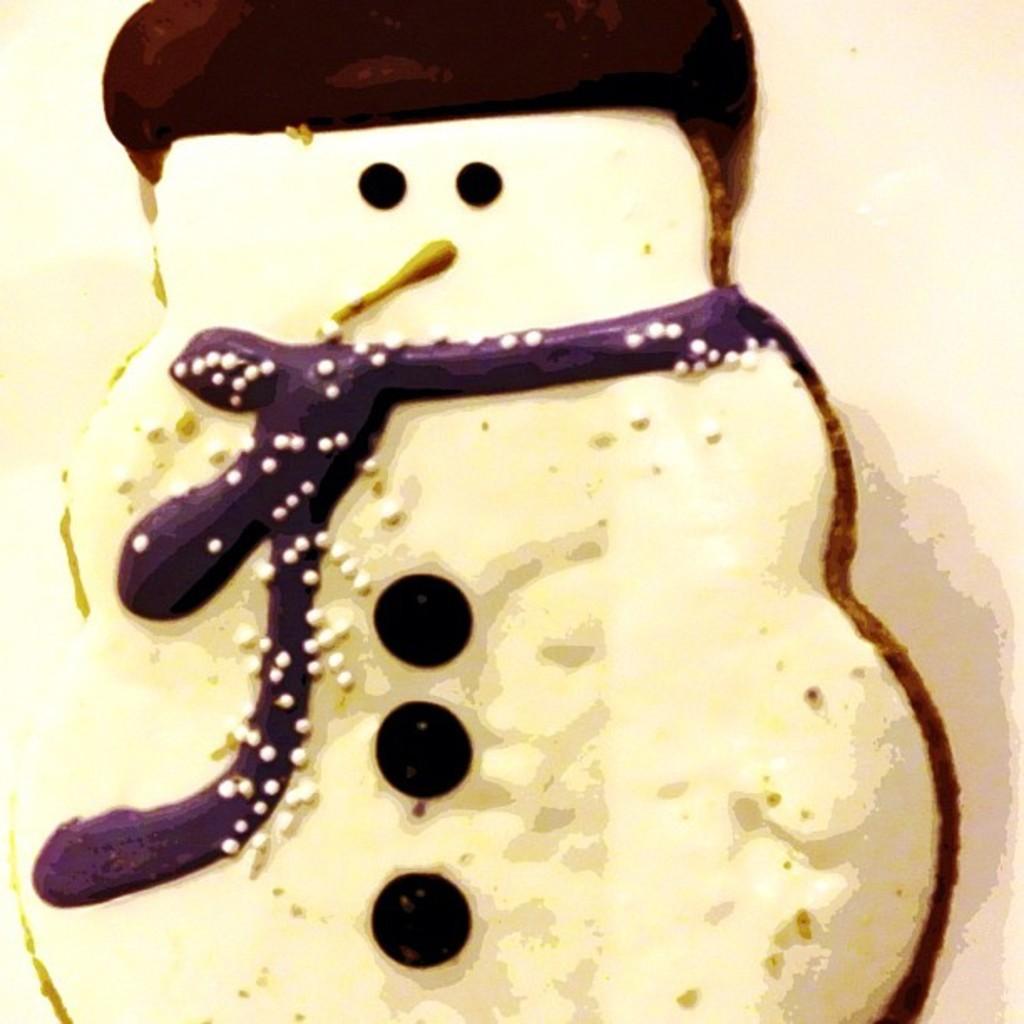How would you summarize this image in a sentence or two? Here we can see a cookie in the shape of snowman. 